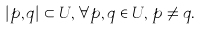<formula> <loc_0><loc_0><loc_500><loc_500>| p , q | \subset U , \, \forall p , q \in U , \, p \neq q .</formula> 